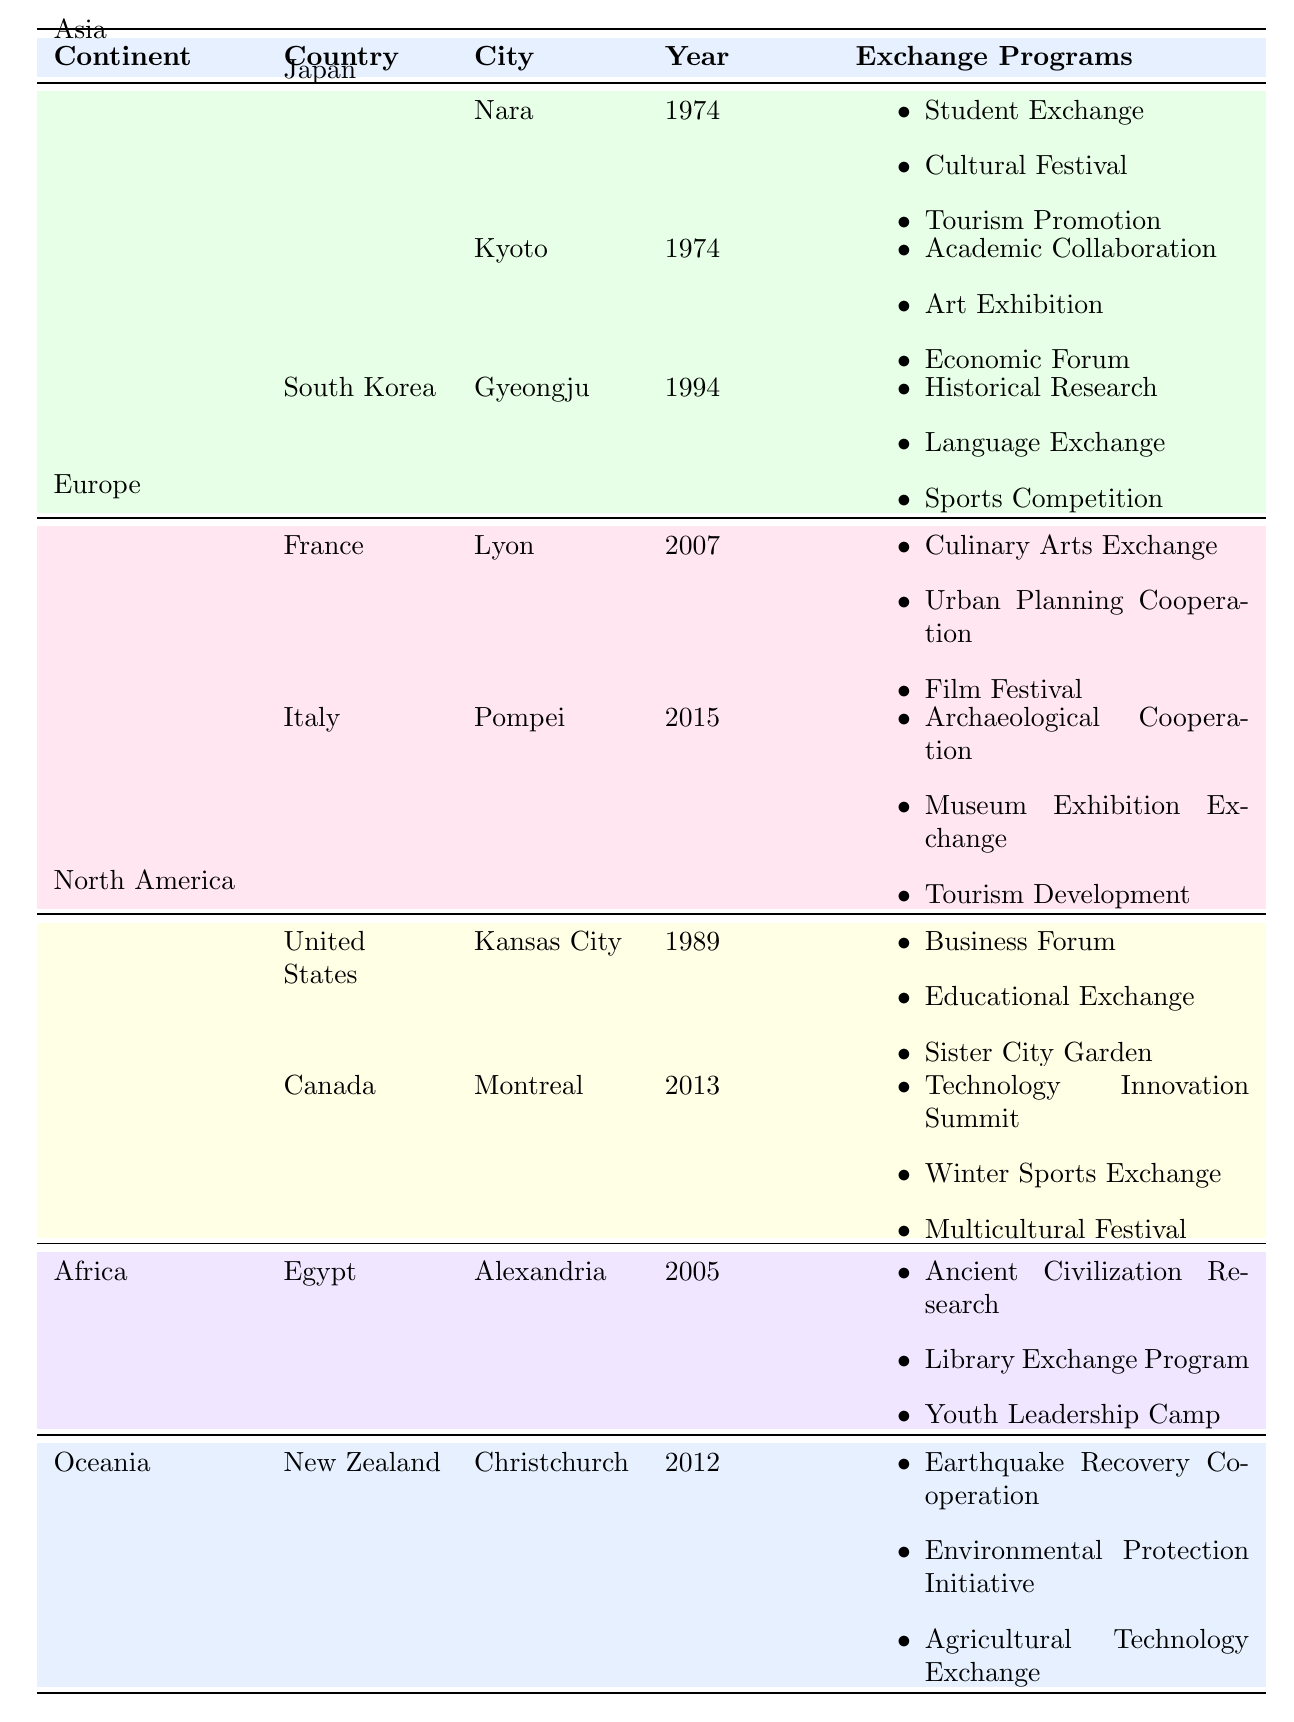What continent has the most sister city agreements for Xi'an? The table shows agreements categorized by continent. Asia has the most entries, with three countries listed.
Answer: Asia Which city in Japan was established as a sister city with Xi'an first? The city of Nara was established in 1974, the earliest among the Japanese cities listed.
Answer: Nara How many exchange programs does the city of Lyon in France have? Lyon has three exchange programs listed: Culinary Arts Exchange, Urban Planning Cooperation, and Film Festival.
Answer: 3 Is there an exchange program between Xi'an and a city in Canada? Yes, Montreal in Canada has three exchange programs with Xi'an.
Answer: Yes Which country has the latest sister city agreement established with Xi'an in Europe? Italy has the latest agreement, established in 2015 with the city of Pompei.
Answer: Italy How many total exchange programs are listed for sister cities in North America? Kansas City has three exchange programs and Montreal also has three, totaling six.
Answer: 6 What are the exchange programs associated with the city of Gyeongju in South Korea? The exchange programs are: Historical Research, Language Exchange, and Sports Competition.
Answer: Historical Research, Language Exchange, Sports Competition Which continent has only one country listed for sister city agreements? Africa has only one country listed, which is Egypt.
Answer: Africa Which city has the exchange program focused on Environmental Protection Initiative? Christchurch in New Zealand has the exchange program focused on Environmental Protection Initiative.
Answer: Christchurch Are there any cities in Asia established after 1990? No, all cities in Asia listed have been established before 1990; Gyeongju was established in 1994.
Answer: No 